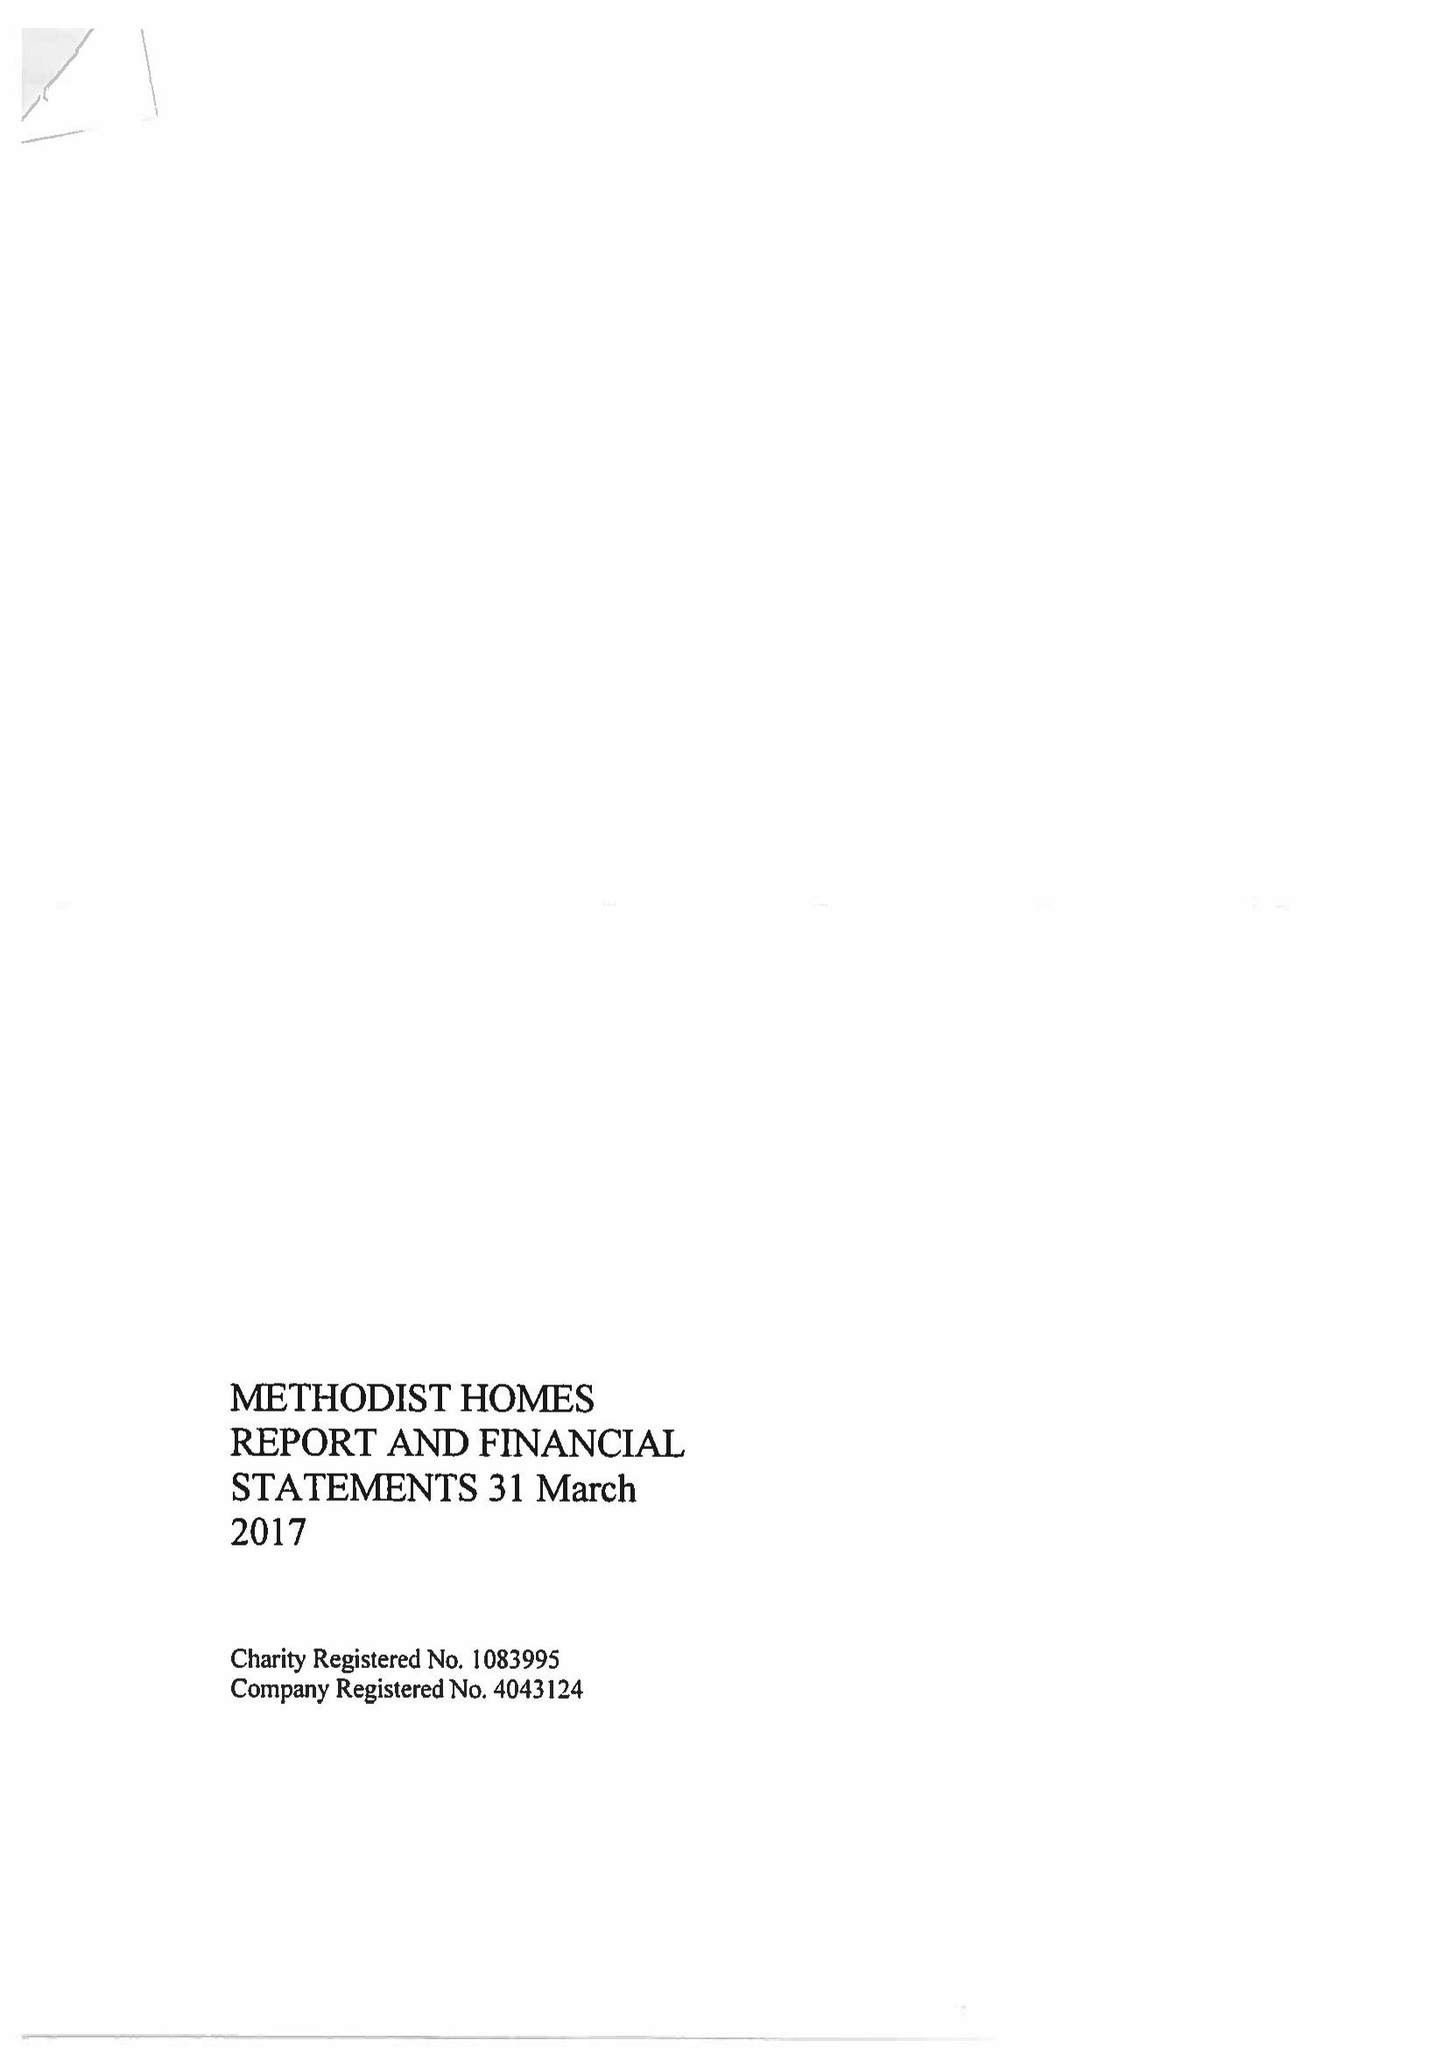What is the value for the charity_name?
Answer the question using a single word or phrase. Methodist Homes 